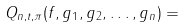Convert formula to latex. <formula><loc_0><loc_0><loc_500><loc_500>Q _ { n , t , \pi } ( f , g _ { 1 } , g _ { 2 } , \dots , g _ { n } ) =</formula> 